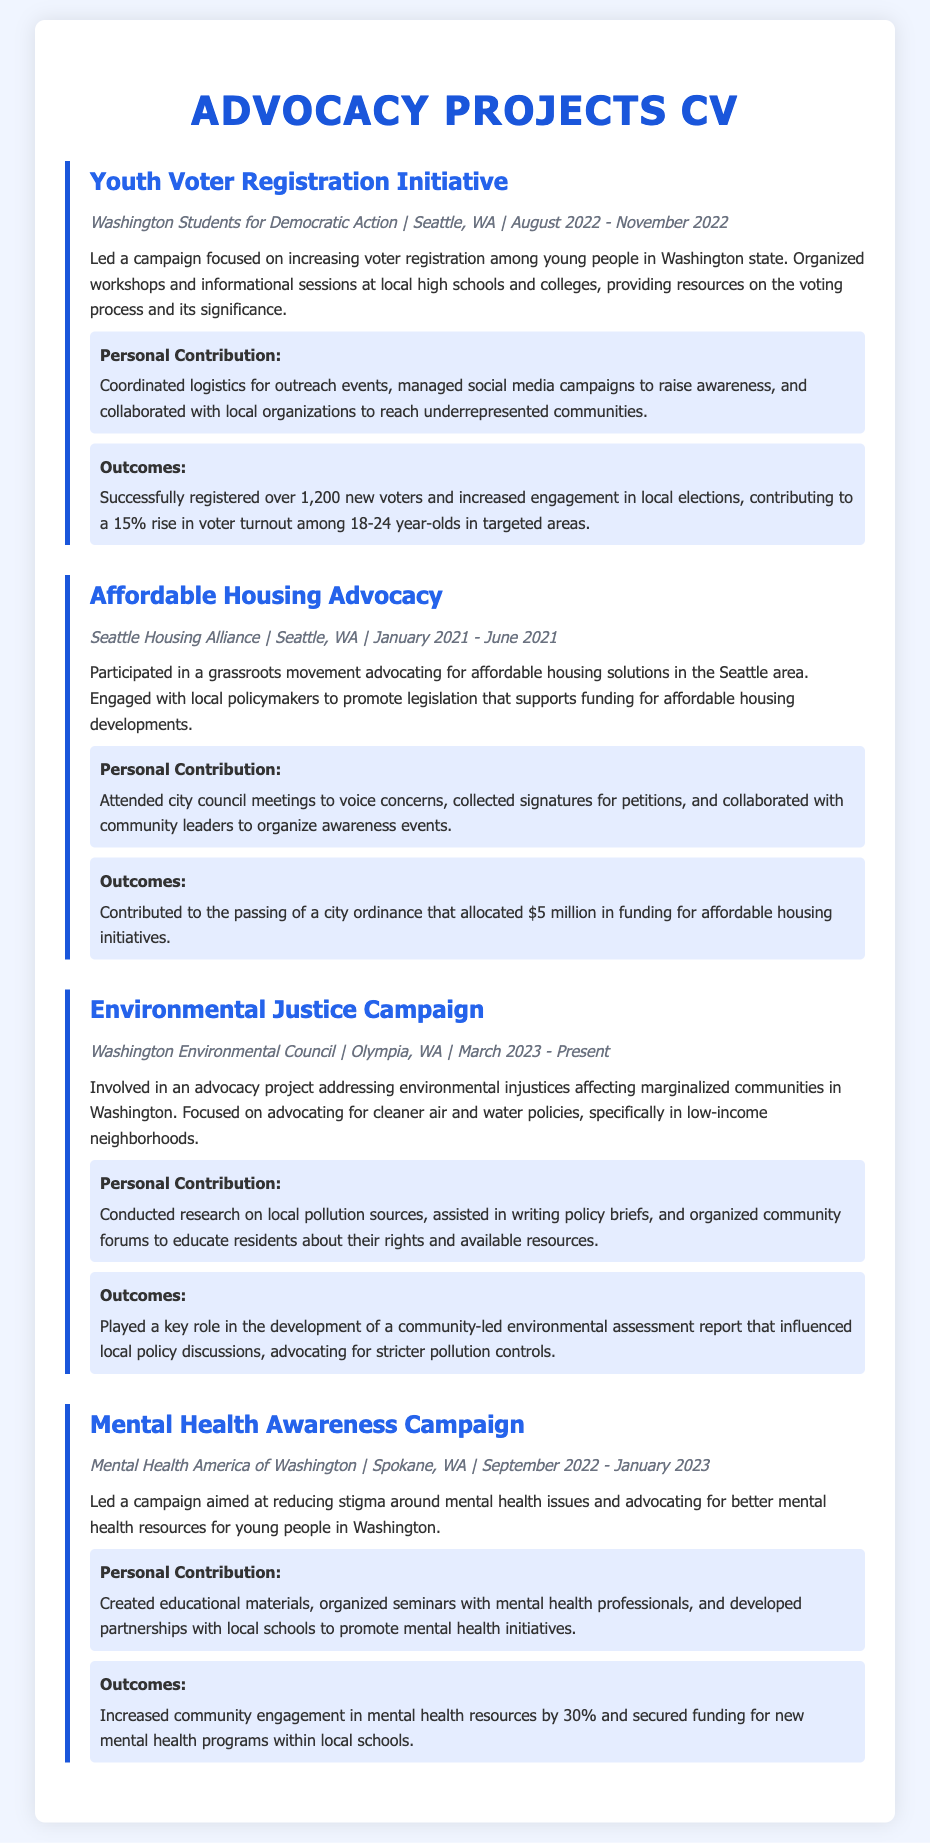What is the title of the first project? The title of the first project listed in the document is "Youth Voter Registration Initiative."
Answer: Youth Voter Registration Initiative What organization was behind the Affordable Housing Advocacy? The organization involved in the Affordable Housing Advocacy project is the Seattle Housing Alliance.
Answer: Seattle Housing Alliance When did the Environmental Justice Campaign start? The Environmental Justice Campaign began in March 2023, as stated in the document.
Answer: March 2023 How many new voters were successfully registered during the Youth Voter Registration Initiative? The document states that over 1,200 new voters were registered through the initiative.
Answer: 1,200 What was allocated for affordable housing initiatives as a result of the Affordable Housing Advocacy? The document mentions that $5 million was allocated for affordable housing initiatives.
Answer: $5 million How much did engagement in mental health resources increase as a result of the Mental Health Awareness Campaign? The document indicates that community engagement in mental health resources increased by 30%.
Answer: 30% What is the main focus of the Environmental Justice Campaign? The main focus of the Environmental Justice Campaign is advocating for cleaner air and water policies.
Answer: Cleaner air and water policies Which project involved organizing workshops and informational sessions? The Youth Voter Registration Initiative involved organizing workshops and informational sessions.
Answer: Youth Voter Registration Initiative What type of campaign was led by Mental Health America of Washington? The campaign led by Mental Health America of Washington was aimed at reducing stigma around mental health issues.
Answer: Reducing stigma around mental health issues 